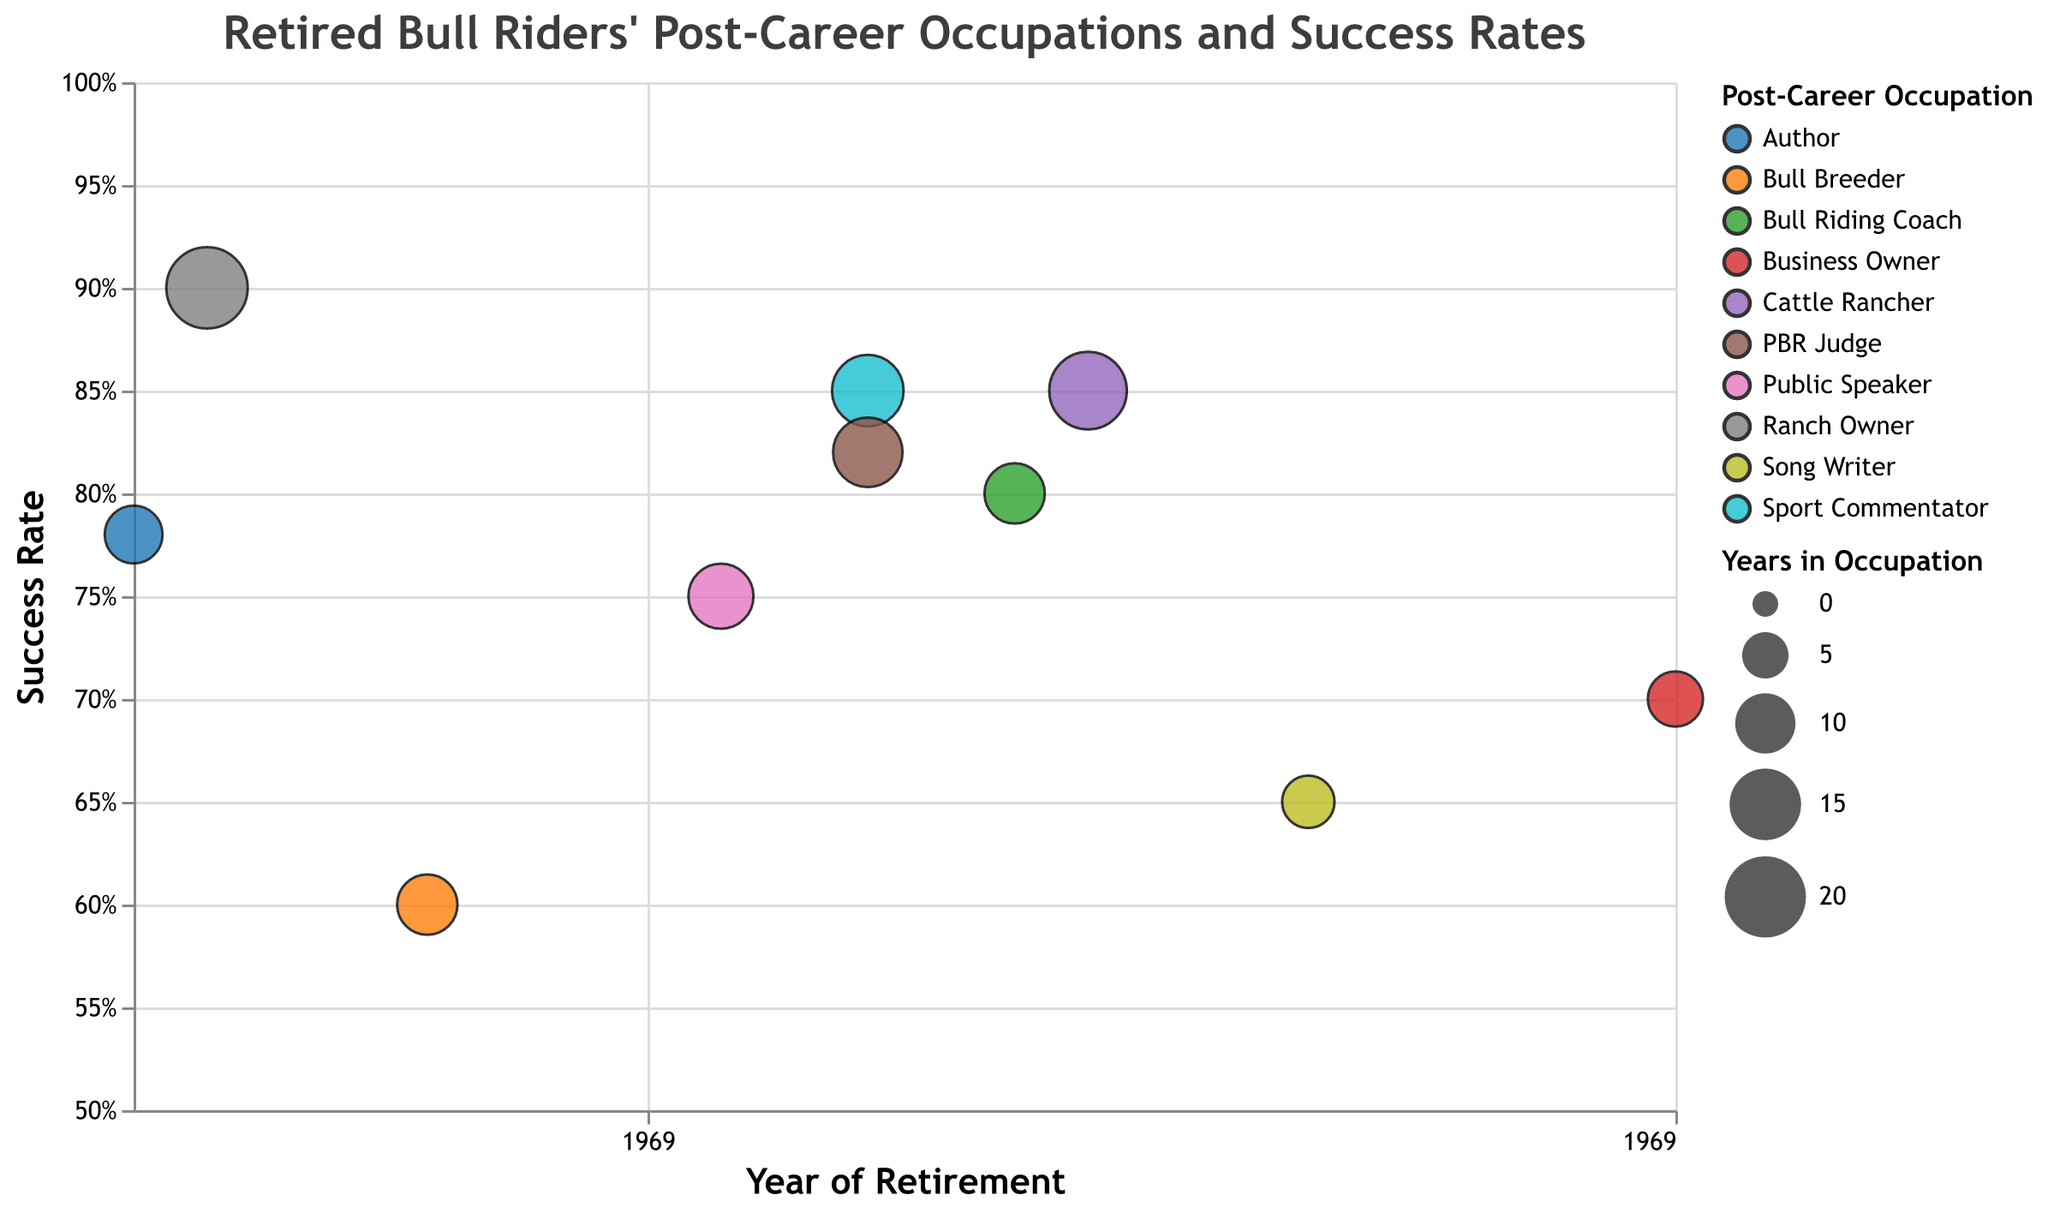What's the highest success rate among the retired bull riders and who achieved it? The figure shows the success rates on the y-axis. Lane Frost has the highest success rate of 0.90.
Answer: Lane Frost Which occupation has the largest bubble size and who represents it? The bubble size represents the number of years in the occupation. Lane Frost, as a Ranch Owner, has the largest bubble with 20 years.
Answer: Ranch Owner, Lane Frost How many retired bull riders have a success rate of 0.80 or higher? By counting the bubbles on the y-axis that are at or above 0.80, we count: Ty Murray, Lane Frost, Tuff Hedeman, Jim Sharp, Jerome Davis, Don Gay. That sums to 6.
Answer: 6 Which rider retired the most recently and what is their post-career occupation? The x-axis shows the retirement year. Chris Shivers retired in 2013 and is now a Business Owner.
Answer: Chris Shivers, Business Owner Which occupation has both the lowest success rate and the shortest duration, and who is it? By observing the y-axis for the lowest point (0.60) and the size of the bubble, we can find Charles Sampson, a Bull Breeder with 10 years.
Answer: Bull Breeder, Charles Sampson Which retired riders embarked on a new career immediately after 2000 and what are their success rates? Checking the x-axis for points starting after the year 2000 shows: Ty Murray (2002), Tuff Hedeman (2004), Jim Sharp (2005), Justin McBride (2008), Chris Shivers (2013). Their success rates are 0.85, 0.80, 0.85, 0.65, 0.70 respectively.
Answer: Ty Murray (0.85), Tuff Hedeman (0.80), Jim Sharp (0.85), Justin McBride (0.65), Chris Shivers (0.70) Which occupation has the most diversity in the number of retired bull riders (considering the color legend)? The color legend represents different post-career occupations. Each unique color represents a different occupation, with no repeated occupation among the listed riders. Therefore, each occupation has only one representative.
Answer: Each occupation has 1 representative 